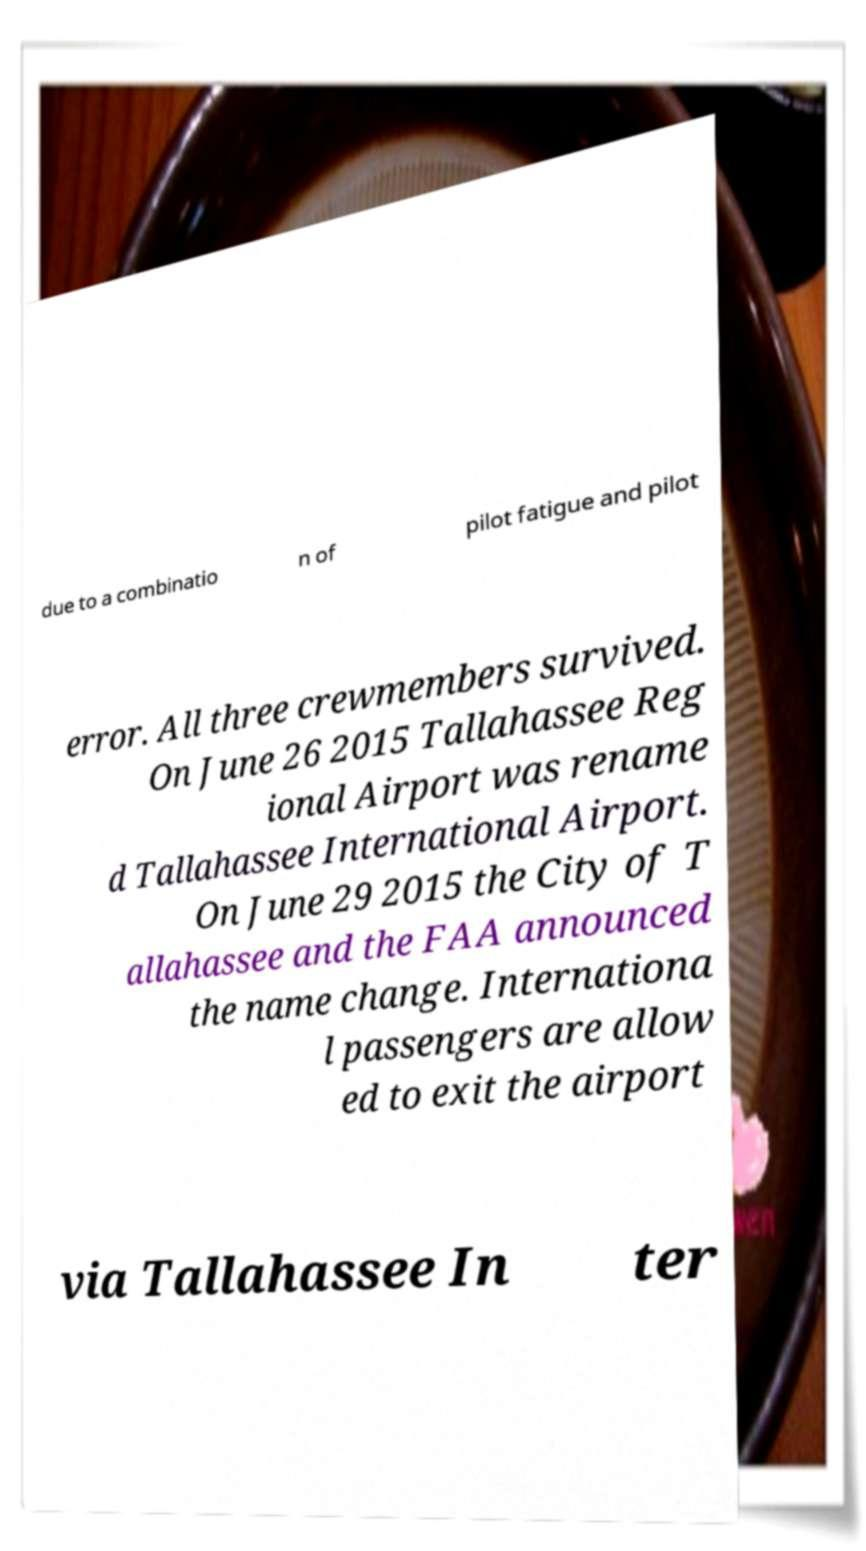Can you read and provide the text displayed in the image?This photo seems to have some interesting text. Can you extract and type it out for me? due to a combinatio n of pilot fatigue and pilot error. All three crewmembers survived. On June 26 2015 Tallahassee Reg ional Airport was rename d Tallahassee International Airport. On June 29 2015 the City of T allahassee and the FAA announced the name change. Internationa l passengers are allow ed to exit the airport via Tallahassee In ter 